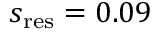Convert formula to latex. <formula><loc_0><loc_0><loc_500><loc_500>s _ { r e s } = 0 . 0 9</formula> 